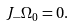<formula> <loc_0><loc_0><loc_500><loc_500>J _ { - } \Omega _ { 0 } = 0 .</formula> 